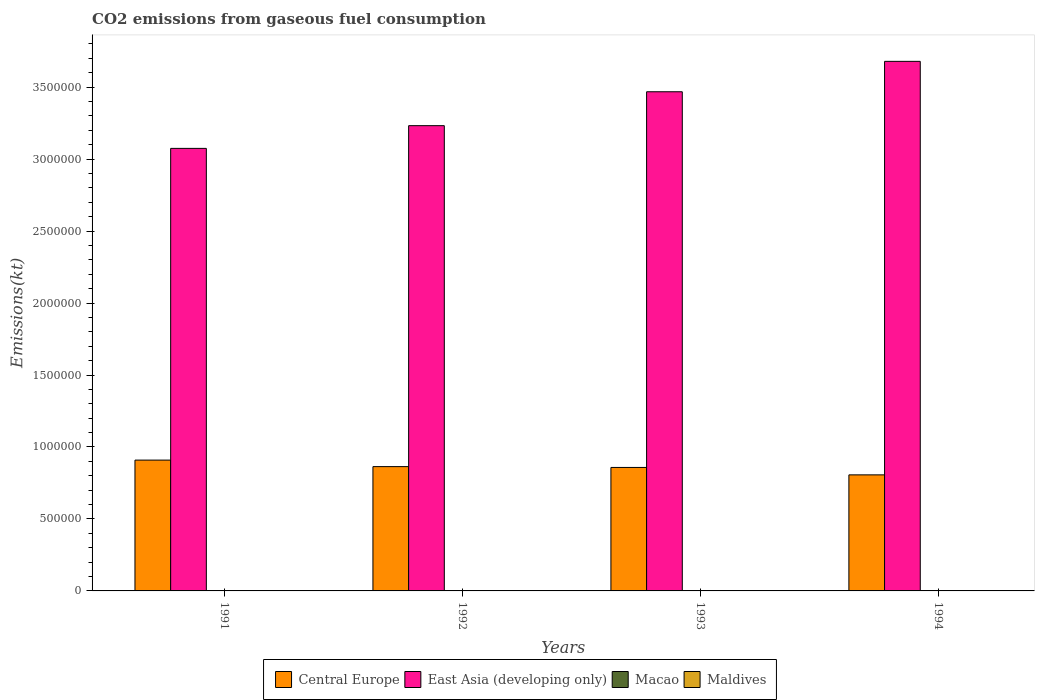How many different coloured bars are there?
Provide a short and direct response. 4. How many groups of bars are there?
Give a very brief answer. 4. Are the number of bars per tick equal to the number of legend labels?
Make the answer very short. Yes. Are the number of bars on each tick of the X-axis equal?
Make the answer very short. Yes. How many bars are there on the 4th tick from the left?
Ensure brevity in your answer.  4. How many bars are there on the 3rd tick from the right?
Your response must be concise. 4. What is the amount of CO2 emitted in Macao in 1994?
Your response must be concise. 1283.45. Across all years, what is the maximum amount of CO2 emitted in East Asia (developing only)?
Ensure brevity in your answer.  3.68e+06. Across all years, what is the minimum amount of CO2 emitted in Maldives?
Make the answer very short. 172.35. In which year was the amount of CO2 emitted in East Asia (developing only) minimum?
Make the answer very short. 1991. What is the total amount of CO2 emitted in East Asia (developing only) in the graph?
Keep it short and to the point. 1.35e+07. What is the difference between the amount of CO2 emitted in Central Europe in 1993 and that in 1994?
Make the answer very short. 5.15e+04. What is the difference between the amount of CO2 emitted in Macao in 1992 and the amount of CO2 emitted in Maldives in 1994?
Provide a short and direct response. 865.41. What is the average amount of CO2 emitted in Macao per year?
Give a very brief answer. 1162.44. In the year 1991, what is the difference between the amount of CO2 emitted in Maldives and amount of CO2 emitted in East Asia (developing only)?
Offer a very short reply. -3.07e+06. What is the ratio of the amount of CO2 emitted in Maldives in 1991 to that in 1994?
Your answer should be very brief. 0.78. What is the difference between the highest and the second highest amount of CO2 emitted in Maldives?
Offer a very short reply. 33. What is the difference between the highest and the lowest amount of CO2 emitted in East Asia (developing only)?
Your response must be concise. 6.05e+05. Is the sum of the amount of CO2 emitted in Macao in 1992 and 1994 greater than the maximum amount of CO2 emitted in Central Europe across all years?
Ensure brevity in your answer.  No. What does the 1st bar from the left in 1994 represents?
Give a very brief answer. Central Europe. What does the 1st bar from the right in 1991 represents?
Ensure brevity in your answer.  Maldives. Is it the case that in every year, the sum of the amount of CO2 emitted in East Asia (developing only) and amount of CO2 emitted in Macao is greater than the amount of CO2 emitted in Central Europe?
Give a very brief answer. Yes. Are all the bars in the graph horizontal?
Provide a short and direct response. No. How many years are there in the graph?
Offer a terse response. 4. What is the difference between two consecutive major ticks on the Y-axis?
Your answer should be compact. 5.00e+05. Does the graph contain grids?
Give a very brief answer. No. How many legend labels are there?
Make the answer very short. 4. How are the legend labels stacked?
Provide a succinct answer. Horizontal. What is the title of the graph?
Offer a very short reply. CO2 emissions from gaseous fuel consumption. Does "American Samoa" appear as one of the legend labels in the graph?
Provide a short and direct response. No. What is the label or title of the Y-axis?
Offer a terse response. Emissions(kt). What is the Emissions(kt) of Central Europe in 1991?
Offer a very short reply. 9.09e+05. What is the Emissions(kt) of East Asia (developing only) in 1991?
Keep it short and to the point. 3.07e+06. What is the Emissions(kt) in Macao in 1991?
Offer a terse response. 1092.77. What is the Emissions(kt) in Maldives in 1991?
Your response must be concise. 172.35. What is the Emissions(kt) of Central Europe in 1992?
Provide a succinct answer. 8.64e+05. What is the Emissions(kt) in East Asia (developing only) in 1992?
Provide a short and direct response. 3.23e+06. What is the Emissions(kt) in Macao in 1992?
Your response must be concise. 1085.43. What is the Emissions(kt) of Maldives in 1992?
Keep it short and to the point. 253.02. What is the Emissions(kt) of Central Europe in 1993?
Offer a very short reply. 8.58e+05. What is the Emissions(kt) of East Asia (developing only) in 1993?
Ensure brevity in your answer.  3.47e+06. What is the Emissions(kt) in Macao in 1993?
Your answer should be very brief. 1188.11. What is the Emissions(kt) of Maldives in 1993?
Your answer should be compact. 216.35. What is the Emissions(kt) of Central Europe in 1994?
Your answer should be very brief. 8.06e+05. What is the Emissions(kt) in East Asia (developing only) in 1994?
Make the answer very short. 3.68e+06. What is the Emissions(kt) of Macao in 1994?
Provide a short and direct response. 1283.45. What is the Emissions(kt) in Maldives in 1994?
Provide a succinct answer. 220.02. Across all years, what is the maximum Emissions(kt) of Central Europe?
Keep it short and to the point. 9.09e+05. Across all years, what is the maximum Emissions(kt) of East Asia (developing only)?
Offer a very short reply. 3.68e+06. Across all years, what is the maximum Emissions(kt) of Macao?
Your response must be concise. 1283.45. Across all years, what is the maximum Emissions(kt) of Maldives?
Provide a succinct answer. 253.02. Across all years, what is the minimum Emissions(kt) in Central Europe?
Your answer should be very brief. 8.06e+05. Across all years, what is the minimum Emissions(kt) in East Asia (developing only)?
Your answer should be very brief. 3.07e+06. Across all years, what is the minimum Emissions(kt) in Macao?
Ensure brevity in your answer.  1085.43. Across all years, what is the minimum Emissions(kt) of Maldives?
Make the answer very short. 172.35. What is the total Emissions(kt) of Central Europe in the graph?
Give a very brief answer. 3.44e+06. What is the total Emissions(kt) in East Asia (developing only) in the graph?
Your response must be concise. 1.35e+07. What is the total Emissions(kt) of Macao in the graph?
Make the answer very short. 4649.76. What is the total Emissions(kt) in Maldives in the graph?
Offer a very short reply. 861.75. What is the difference between the Emissions(kt) of Central Europe in 1991 and that in 1992?
Ensure brevity in your answer.  4.53e+04. What is the difference between the Emissions(kt) of East Asia (developing only) in 1991 and that in 1992?
Your answer should be compact. -1.58e+05. What is the difference between the Emissions(kt) of Macao in 1991 and that in 1992?
Ensure brevity in your answer.  7.33. What is the difference between the Emissions(kt) in Maldives in 1991 and that in 1992?
Provide a short and direct response. -80.67. What is the difference between the Emissions(kt) in Central Europe in 1991 and that in 1993?
Your response must be concise. 5.11e+04. What is the difference between the Emissions(kt) in East Asia (developing only) in 1991 and that in 1993?
Ensure brevity in your answer.  -3.93e+05. What is the difference between the Emissions(kt) of Macao in 1991 and that in 1993?
Your answer should be very brief. -95.34. What is the difference between the Emissions(kt) in Maldives in 1991 and that in 1993?
Offer a very short reply. -44. What is the difference between the Emissions(kt) of Central Europe in 1991 and that in 1994?
Your answer should be very brief. 1.03e+05. What is the difference between the Emissions(kt) of East Asia (developing only) in 1991 and that in 1994?
Offer a very short reply. -6.05e+05. What is the difference between the Emissions(kt) of Macao in 1991 and that in 1994?
Ensure brevity in your answer.  -190.68. What is the difference between the Emissions(kt) in Maldives in 1991 and that in 1994?
Offer a very short reply. -47.67. What is the difference between the Emissions(kt) in Central Europe in 1992 and that in 1993?
Offer a terse response. 5808.53. What is the difference between the Emissions(kt) of East Asia (developing only) in 1992 and that in 1993?
Your answer should be very brief. -2.36e+05. What is the difference between the Emissions(kt) of Macao in 1992 and that in 1993?
Keep it short and to the point. -102.68. What is the difference between the Emissions(kt) in Maldives in 1992 and that in 1993?
Give a very brief answer. 36.67. What is the difference between the Emissions(kt) of Central Europe in 1992 and that in 1994?
Provide a succinct answer. 5.73e+04. What is the difference between the Emissions(kt) of East Asia (developing only) in 1992 and that in 1994?
Provide a short and direct response. -4.47e+05. What is the difference between the Emissions(kt) of Macao in 1992 and that in 1994?
Offer a terse response. -198.02. What is the difference between the Emissions(kt) of Maldives in 1992 and that in 1994?
Give a very brief answer. 33. What is the difference between the Emissions(kt) in Central Europe in 1993 and that in 1994?
Provide a short and direct response. 5.15e+04. What is the difference between the Emissions(kt) of East Asia (developing only) in 1993 and that in 1994?
Offer a very short reply. -2.11e+05. What is the difference between the Emissions(kt) of Macao in 1993 and that in 1994?
Provide a succinct answer. -95.34. What is the difference between the Emissions(kt) of Maldives in 1993 and that in 1994?
Offer a terse response. -3.67. What is the difference between the Emissions(kt) in Central Europe in 1991 and the Emissions(kt) in East Asia (developing only) in 1992?
Make the answer very short. -2.32e+06. What is the difference between the Emissions(kt) of Central Europe in 1991 and the Emissions(kt) of Macao in 1992?
Give a very brief answer. 9.08e+05. What is the difference between the Emissions(kt) of Central Europe in 1991 and the Emissions(kt) of Maldives in 1992?
Your answer should be compact. 9.09e+05. What is the difference between the Emissions(kt) of East Asia (developing only) in 1991 and the Emissions(kt) of Macao in 1992?
Provide a succinct answer. 3.07e+06. What is the difference between the Emissions(kt) of East Asia (developing only) in 1991 and the Emissions(kt) of Maldives in 1992?
Offer a very short reply. 3.07e+06. What is the difference between the Emissions(kt) of Macao in 1991 and the Emissions(kt) of Maldives in 1992?
Make the answer very short. 839.74. What is the difference between the Emissions(kt) of Central Europe in 1991 and the Emissions(kt) of East Asia (developing only) in 1993?
Ensure brevity in your answer.  -2.56e+06. What is the difference between the Emissions(kt) in Central Europe in 1991 and the Emissions(kt) in Macao in 1993?
Provide a succinct answer. 9.08e+05. What is the difference between the Emissions(kt) in Central Europe in 1991 and the Emissions(kt) in Maldives in 1993?
Make the answer very short. 9.09e+05. What is the difference between the Emissions(kt) in East Asia (developing only) in 1991 and the Emissions(kt) in Macao in 1993?
Ensure brevity in your answer.  3.07e+06. What is the difference between the Emissions(kt) of East Asia (developing only) in 1991 and the Emissions(kt) of Maldives in 1993?
Make the answer very short. 3.07e+06. What is the difference between the Emissions(kt) of Macao in 1991 and the Emissions(kt) of Maldives in 1993?
Offer a terse response. 876.41. What is the difference between the Emissions(kt) of Central Europe in 1991 and the Emissions(kt) of East Asia (developing only) in 1994?
Offer a very short reply. -2.77e+06. What is the difference between the Emissions(kt) of Central Europe in 1991 and the Emissions(kt) of Macao in 1994?
Offer a very short reply. 9.08e+05. What is the difference between the Emissions(kt) in Central Europe in 1991 and the Emissions(kt) in Maldives in 1994?
Your answer should be compact. 9.09e+05. What is the difference between the Emissions(kt) in East Asia (developing only) in 1991 and the Emissions(kt) in Macao in 1994?
Offer a terse response. 3.07e+06. What is the difference between the Emissions(kt) in East Asia (developing only) in 1991 and the Emissions(kt) in Maldives in 1994?
Ensure brevity in your answer.  3.07e+06. What is the difference between the Emissions(kt) of Macao in 1991 and the Emissions(kt) of Maldives in 1994?
Ensure brevity in your answer.  872.75. What is the difference between the Emissions(kt) of Central Europe in 1992 and the Emissions(kt) of East Asia (developing only) in 1993?
Your response must be concise. -2.60e+06. What is the difference between the Emissions(kt) of Central Europe in 1992 and the Emissions(kt) of Macao in 1993?
Ensure brevity in your answer.  8.62e+05. What is the difference between the Emissions(kt) of Central Europe in 1992 and the Emissions(kt) of Maldives in 1993?
Provide a succinct answer. 8.63e+05. What is the difference between the Emissions(kt) in East Asia (developing only) in 1992 and the Emissions(kt) in Macao in 1993?
Provide a succinct answer. 3.23e+06. What is the difference between the Emissions(kt) in East Asia (developing only) in 1992 and the Emissions(kt) in Maldives in 1993?
Your response must be concise. 3.23e+06. What is the difference between the Emissions(kt) of Macao in 1992 and the Emissions(kt) of Maldives in 1993?
Offer a very short reply. 869.08. What is the difference between the Emissions(kt) of Central Europe in 1992 and the Emissions(kt) of East Asia (developing only) in 1994?
Your answer should be very brief. -2.82e+06. What is the difference between the Emissions(kt) of Central Europe in 1992 and the Emissions(kt) of Macao in 1994?
Offer a very short reply. 8.62e+05. What is the difference between the Emissions(kt) in Central Europe in 1992 and the Emissions(kt) in Maldives in 1994?
Your answer should be compact. 8.63e+05. What is the difference between the Emissions(kt) of East Asia (developing only) in 1992 and the Emissions(kt) of Macao in 1994?
Give a very brief answer. 3.23e+06. What is the difference between the Emissions(kt) of East Asia (developing only) in 1992 and the Emissions(kt) of Maldives in 1994?
Keep it short and to the point. 3.23e+06. What is the difference between the Emissions(kt) of Macao in 1992 and the Emissions(kt) of Maldives in 1994?
Provide a succinct answer. 865.41. What is the difference between the Emissions(kt) of Central Europe in 1993 and the Emissions(kt) of East Asia (developing only) in 1994?
Provide a short and direct response. -2.82e+06. What is the difference between the Emissions(kt) in Central Europe in 1993 and the Emissions(kt) in Macao in 1994?
Your answer should be compact. 8.57e+05. What is the difference between the Emissions(kt) in Central Europe in 1993 and the Emissions(kt) in Maldives in 1994?
Make the answer very short. 8.58e+05. What is the difference between the Emissions(kt) of East Asia (developing only) in 1993 and the Emissions(kt) of Macao in 1994?
Make the answer very short. 3.47e+06. What is the difference between the Emissions(kt) in East Asia (developing only) in 1993 and the Emissions(kt) in Maldives in 1994?
Provide a succinct answer. 3.47e+06. What is the difference between the Emissions(kt) in Macao in 1993 and the Emissions(kt) in Maldives in 1994?
Ensure brevity in your answer.  968.09. What is the average Emissions(kt) in Central Europe per year?
Give a very brief answer. 8.59e+05. What is the average Emissions(kt) of East Asia (developing only) per year?
Provide a succinct answer. 3.36e+06. What is the average Emissions(kt) of Macao per year?
Your answer should be compact. 1162.44. What is the average Emissions(kt) in Maldives per year?
Your response must be concise. 215.44. In the year 1991, what is the difference between the Emissions(kt) of Central Europe and Emissions(kt) of East Asia (developing only)?
Your response must be concise. -2.17e+06. In the year 1991, what is the difference between the Emissions(kt) in Central Europe and Emissions(kt) in Macao?
Provide a succinct answer. 9.08e+05. In the year 1991, what is the difference between the Emissions(kt) of Central Europe and Emissions(kt) of Maldives?
Your answer should be very brief. 9.09e+05. In the year 1991, what is the difference between the Emissions(kt) of East Asia (developing only) and Emissions(kt) of Macao?
Keep it short and to the point. 3.07e+06. In the year 1991, what is the difference between the Emissions(kt) of East Asia (developing only) and Emissions(kt) of Maldives?
Offer a very short reply. 3.07e+06. In the year 1991, what is the difference between the Emissions(kt) in Macao and Emissions(kt) in Maldives?
Provide a succinct answer. 920.42. In the year 1992, what is the difference between the Emissions(kt) in Central Europe and Emissions(kt) in East Asia (developing only)?
Your answer should be compact. -2.37e+06. In the year 1992, what is the difference between the Emissions(kt) of Central Europe and Emissions(kt) of Macao?
Offer a terse response. 8.63e+05. In the year 1992, what is the difference between the Emissions(kt) in Central Europe and Emissions(kt) in Maldives?
Provide a short and direct response. 8.63e+05. In the year 1992, what is the difference between the Emissions(kt) of East Asia (developing only) and Emissions(kt) of Macao?
Provide a succinct answer. 3.23e+06. In the year 1992, what is the difference between the Emissions(kt) in East Asia (developing only) and Emissions(kt) in Maldives?
Your answer should be very brief. 3.23e+06. In the year 1992, what is the difference between the Emissions(kt) of Macao and Emissions(kt) of Maldives?
Make the answer very short. 832.41. In the year 1993, what is the difference between the Emissions(kt) in Central Europe and Emissions(kt) in East Asia (developing only)?
Keep it short and to the point. -2.61e+06. In the year 1993, what is the difference between the Emissions(kt) of Central Europe and Emissions(kt) of Macao?
Your answer should be very brief. 8.57e+05. In the year 1993, what is the difference between the Emissions(kt) of Central Europe and Emissions(kt) of Maldives?
Offer a very short reply. 8.58e+05. In the year 1993, what is the difference between the Emissions(kt) in East Asia (developing only) and Emissions(kt) in Macao?
Provide a succinct answer. 3.47e+06. In the year 1993, what is the difference between the Emissions(kt) of East Asia (developing only) and Emissions(kt) of Maldives?
Provide a succinct answer. 3.47e+06. In the year 1993, what is the difference between the Emissions(kt) in Macao and Emissions(kt) in Maldives?
Make the answer very short. 971.75. In the year 1994, what is the difference between the Emissions(kt) of Central Europe and Emissions(kt) of East Asia (developing only)?
Your response must be concise. -2.87e+06. In the year 1994, what is the difference between the Emissions(kt) of Central Europe and Emissions(kt) of Macao?
Make the answer very short. 8.05e+05. In the year 1994, what is the difference between the Emissions(kt) in Central Europe and Emissions(kt) in Maldives?
Offer a terse response. 8.06e+05. In the year 1994, what is the difference between the Emissions(kt) of East Asia (developing only) and Emissions(kt) of Macao?
Your answer should be compact. 3.68e+06. In the year 1994, what is the difference between the Emissions(kt) of East Asia (developing only) and Emissions(kt) of Maldives?
Your answer should be compact. 3.68e+06. In the year 1994, what is the difference between the Emissions(kt) of Macao and Emissions(kt) of Maldives?
Your response must be concise. 1063.43. What is the ratio of the Emissions(kt) of Central Europe in 1991 to that in 1992?
Your response must be concise. 1.05. What is the ratio of the Emissions(kt) of East Asia (developing only) in 1991 to that in 1992?
Your response must be concise. 0.95. What is the ratio of the Emissions(kt) in Macao in 1991 to that in 1992?
Your response must be concise. 1.01. What is the ratio of the Emissions(kt) of Maldives in 1991 to that in 1992?
Offer a very short reply. 0.68. What is the ratio of the Emissions(kt) of Central Europe in 1991 to that in 1993?
Your answer should be compact. 1.06. What is the ratio of the Emissions(kt) in East Asia (developing only) in 1991 to that in 1993?
Offer a terse response. 0.89. What is the ratio of the Emissions(kt) of Macao in 1991 to that in 1993?
Give a very brief answer. 0.92. What is the ratio of the Emissions(kt) in Maldives in 1991 to that in 1993?
Your response must be concise. 0.8. What is the ratio of the Emissions(kt) in Central Europe in 1991 to that in 1994?
Provide a short and direct response. 1.13. What is the ratio of the Emissions(kt) of East Asia (developing only) in 1991 to that in 1994?
Keep it short and to the point. 0.84. What is the ratio of the Emissions(kt) of Macao in 1991 to that in 1994?
Your response must be concise. 0.85. What is the ratio of the Emissions(kt) in Maldives in 1991 to that in 1994?
Give a very brief answer. 0.78. What is the ratio of the Emissions(kt) in Central Europe in 1992 to that in 1993?
Make the answer very short. 1.01. What is the ratio of the Emissions(kt) in East Asia (developing only) in 1992 to that in 1993?
Give a very brief answer. 0.93. What is the ratio of the Emissions(kt) in Macao in 1992 to that in 1993?
Keep it short and to the point. 0.91. What is the ratio of the Emissions(kt) of Maldives in 1992 to that in 1993?
Provide a short and direct response. 1.17. What is the ratio of the Emissions(kt) in Central Europe in 1992 to that in 1994?
Offer a very short reply. 1.07. What is the ratio of the Emissions(kt) of East Asia (developing only) in 1992 to that in 1994?
Offer a terse response. 0.88. What is the ratio of the Emissions(kt) in Macao in 1992 to that in 1994?
Ensure brevity in your answer.  0.85. What is the ratio of the Emissions(kt) in Maldives in 1992 to that in 1994?
Provide a succinct answer. 1.15. What is the ratio of the Emissions(kt) of Central Europe in 1993 to that in 1994?
Make the answer very short. 1.06. What is the ratio of the Emissions(kt) of East Asia (developing only) in 1993 to that in 1994?
Make the answer very short. 0.94. What is the ratio of the Emissions(kt) in Macao in 1993 to that in 1994?
Provide a short and direct response. 0.93. What is the ratio of the Emissions(kt) of Maldives in 1993 to that in 1994?
Make the answer very short. 0.98. What is the difference between the highest and the second highest Emissions(kt) in Central Europe?
Offer a terse response. 4.53e+04. What is the difference between the highest and the second highest Emissions(kt) of East Asia (developing only)?
Ensure brevity in your answer.  2.11e+05. What is the difference between the highest and the second highest Emissions(kt) of Macao?
Keep it short and to the point. 95.34. What is the difference between the highest and the second highest Emissions(kt) of Maldives?
Provide a short and direct response. 33. What is the difference between the highest and the lowest Emissions(kt) in Central Europe?
Provide a short and direct response. 1.03e+05. What is the difference between the highest and the lowest Emissions(kt) of East Asia (developing only)?
Offer a terse response. 6.05e+05. What is the difference between the highest and the lowest Emissions(kt) of Macao?
Offer a terse response. 198.02. What is the difference between the highest and the lowest Emissions(kt) in Maldives?
Provide a short and direct response. 80.67. 